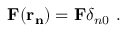Convert formula to latex. <formula><loc_0><loc_0><loc_500><loc_500>{ F ( r _ { n } ) } = { F } \delta _ { n 0 } .</formula> 